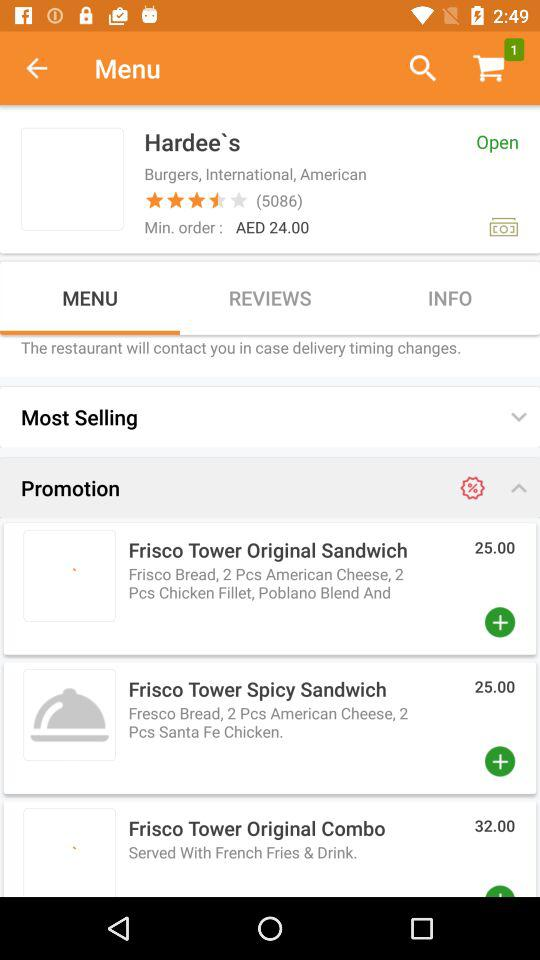What is the price of the "Frisco Tower Spicy Sandwich"? The price is AED 25. 